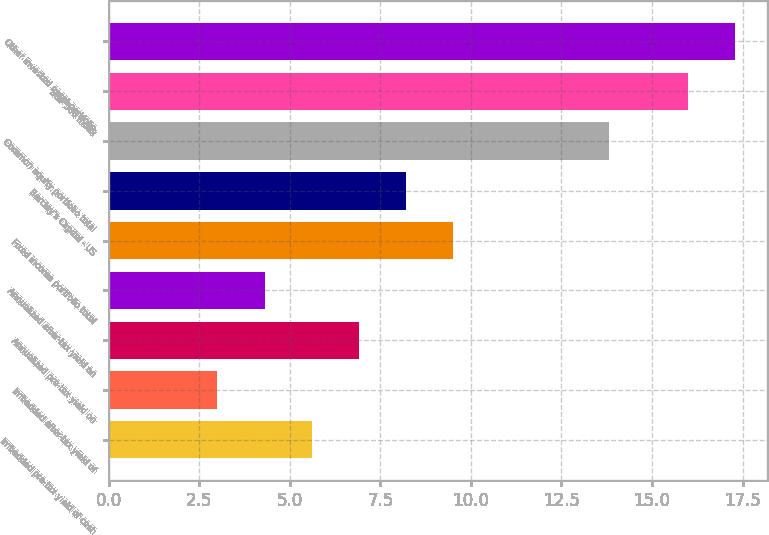<chart> <loc_0><loc_0><loc_500><loc_500><bar_chart><fcel>Imbedded pre-tax yield of cash<fcel>Imbedded after-tax yield of<fcel>Annualized pre-tax yield on<fcel>Annualized after-tax yield on<fcel>Fixed income portfolio total<fcel>Barclay's Capital - US<fcel>Common equity portfolio total<fcel>S&P 500 index<fcel>Other invested asset portfolio<nl><fcel>5.6<fcel>3<fcel>6.9<fcel>4.3<fcel>9.5<fcel>8.2<fcel>13.8<fcel>16<fcel>17.3<nl></chart> 